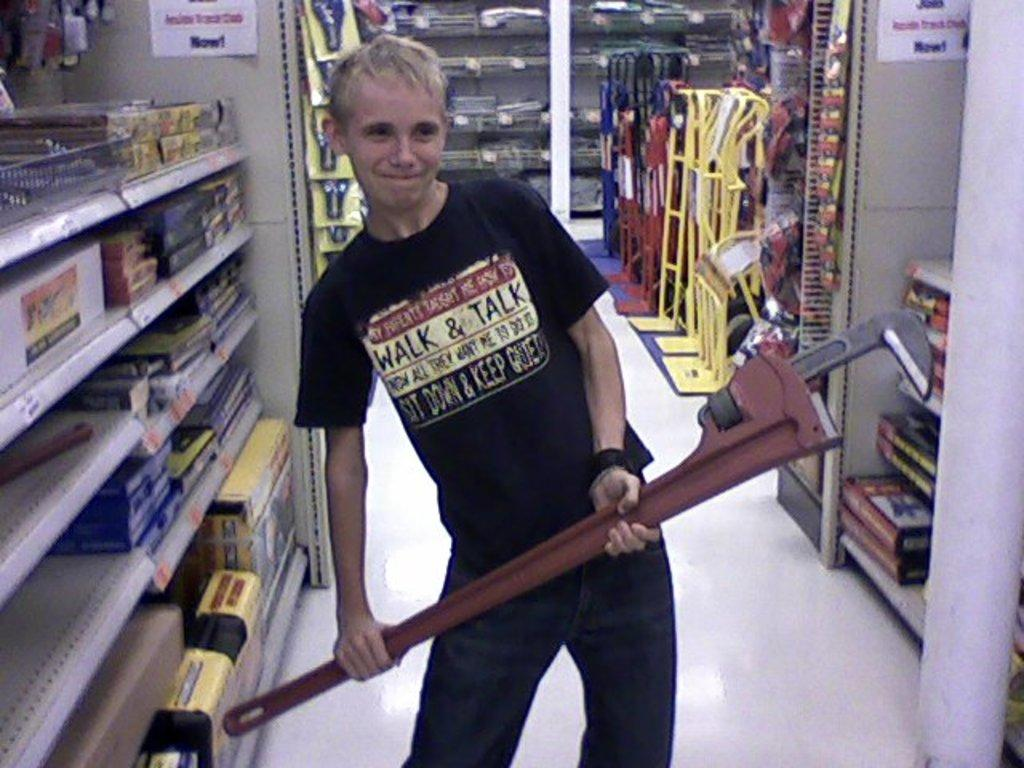<image>
Share a concise interpretation of the image provided. A guy with a black shirt that says "walk and talk". 